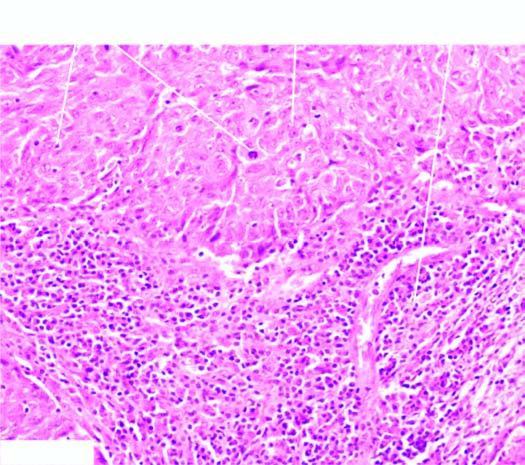re the number of layers infiltrated richly with lymphocytes?
Answer the question using a single word or phrase. No 